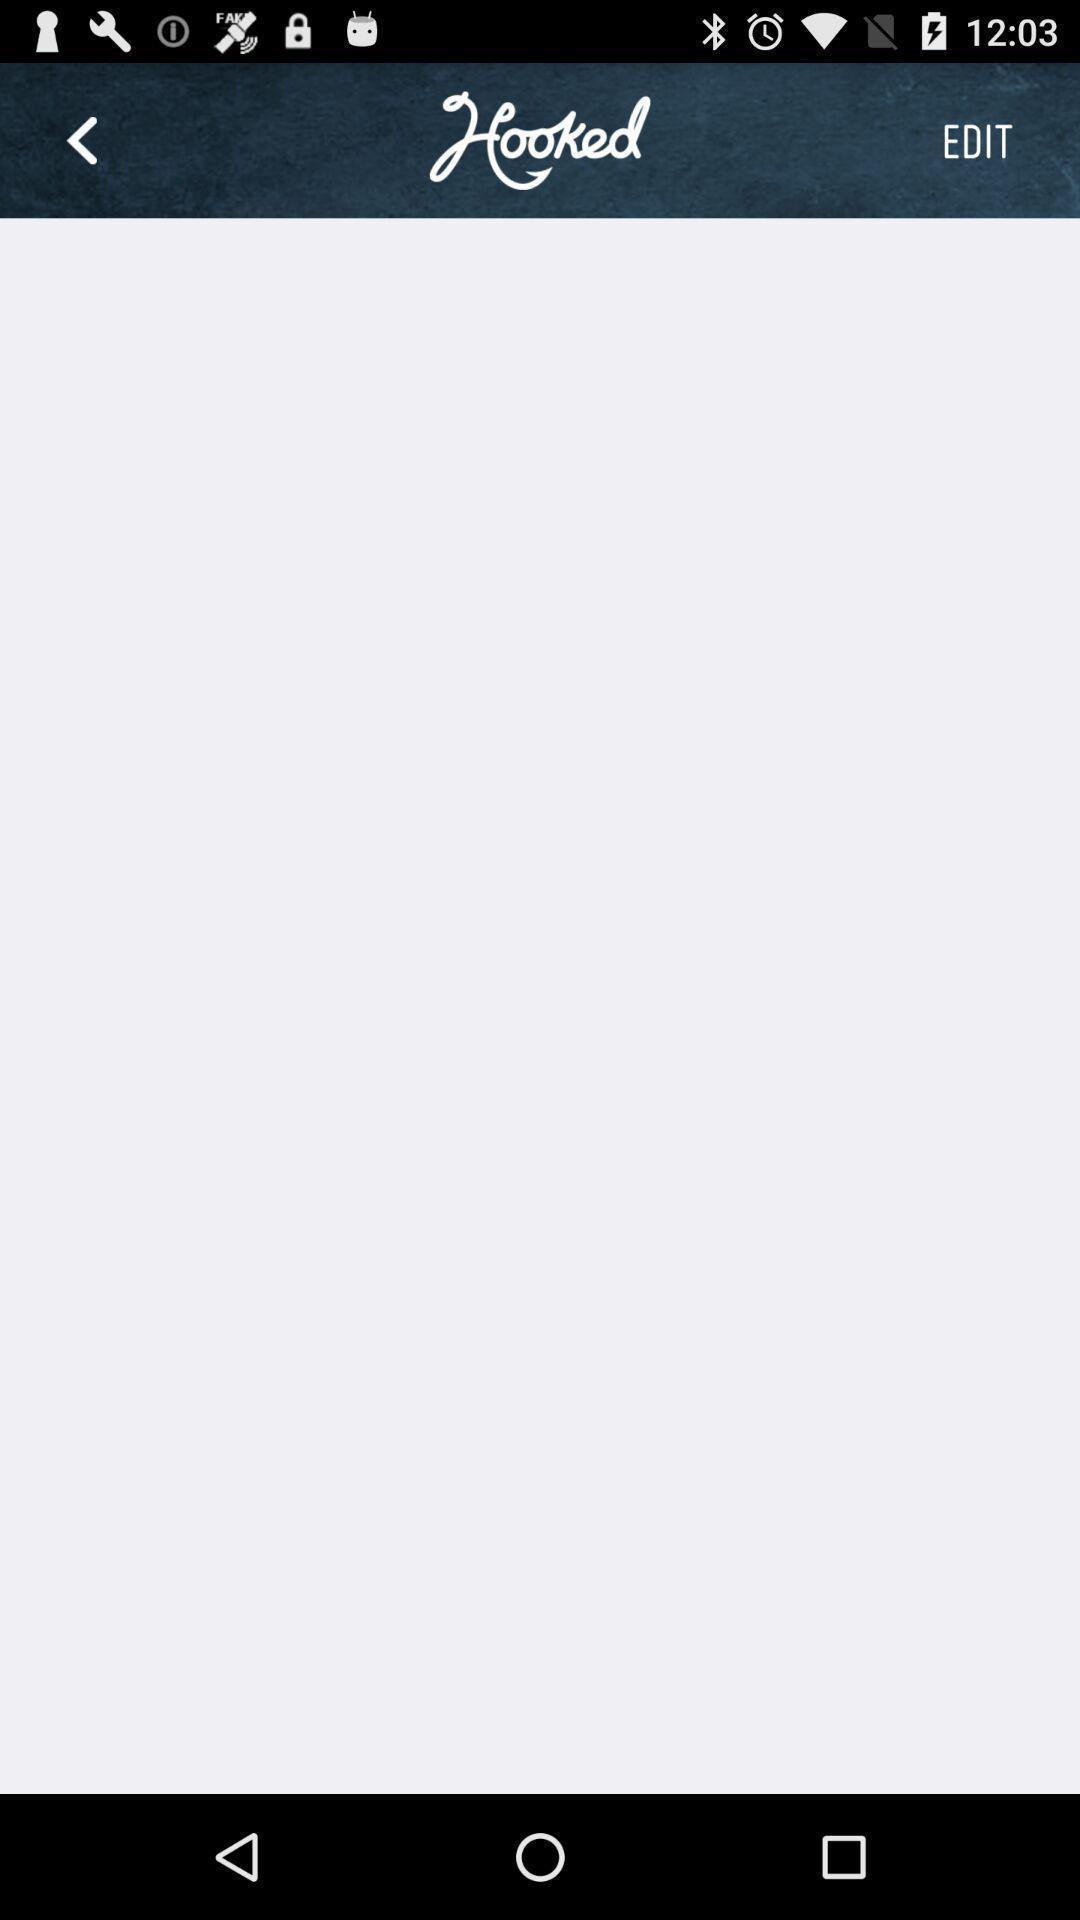Provide a detailed account of this screenshot. Screen shows about an online food app. 